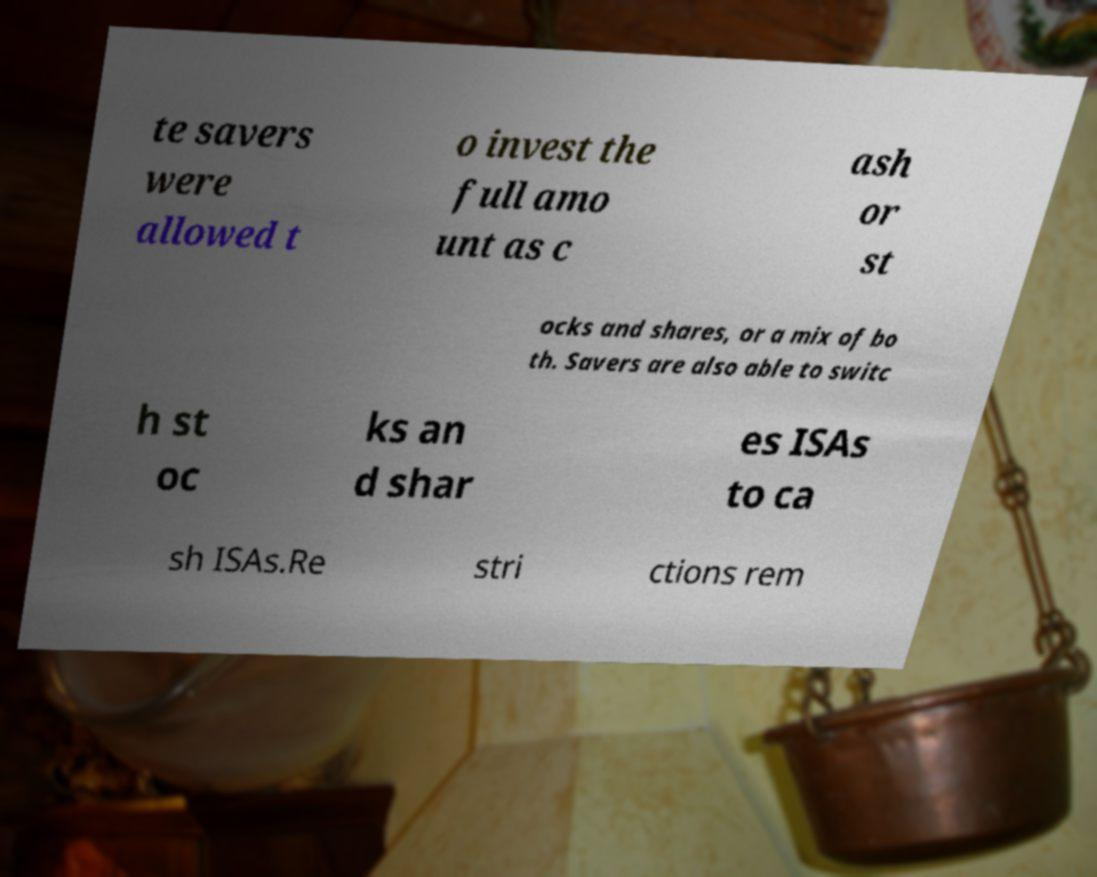For documentation purposes, I need the text within this image transcribed. Could you provide that? te savers were allowed t o invest the full amo unt as c ash or st ocks and shares, or a mix of bo th. Savers are also able to switc h st oc ks an d shar es ISAs to ca sh ISAs.Re stri ctions rem 